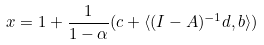Convert formula to latex. <formula><loc_0><loc_0><loc_500><loc_500>x = 1 + \frac { 1 } { 1 - \alpha } ( c + \langle ( I - A ) ^ { - 1 } d , b \rangle )</formula> 